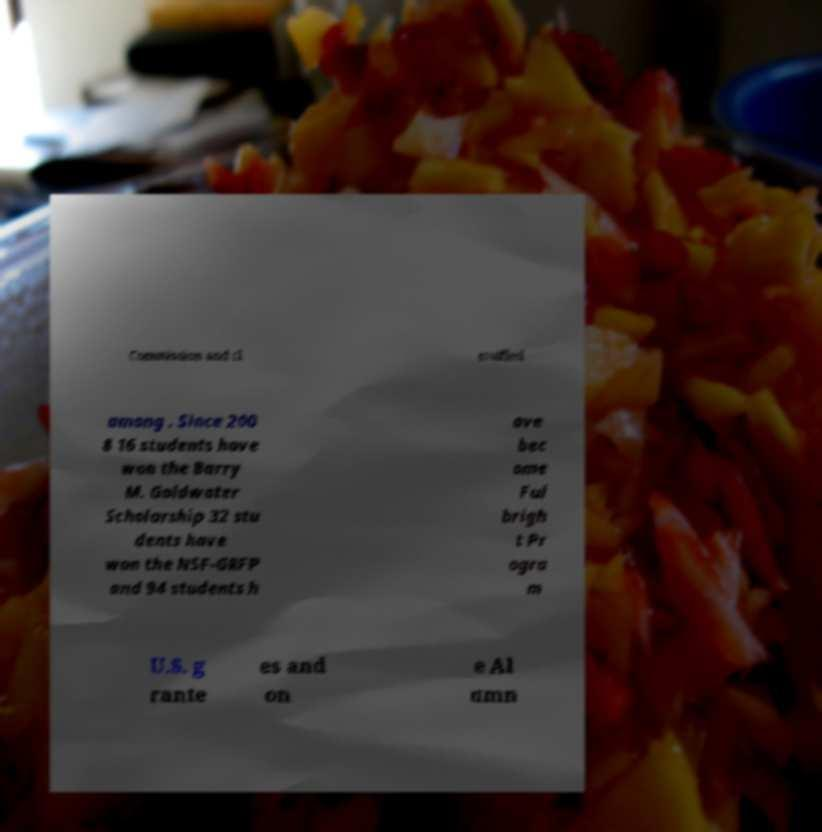Could you assist in decoding the text presented in this image and type it out clearly? Commission and cl assified among . Since 200 8 16 students have won the Barry M. Goldwater Scholarship 32 stu dents have won the NSF-GRFP and 94 students h ave bec ome Ful brigh t Pr ogra m U.S. g rante es and on e Al umn 